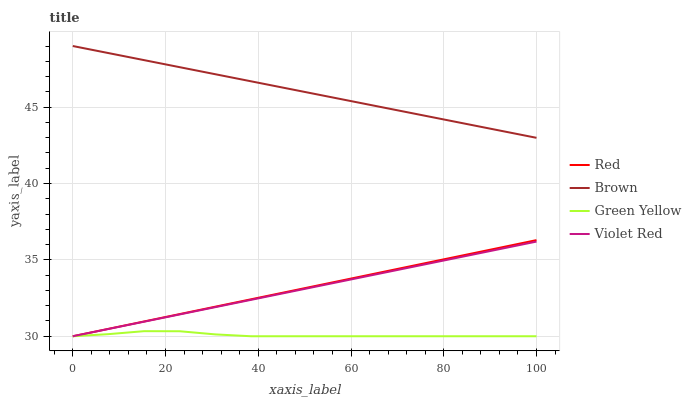Does Green Yellow have the minimum area under the curve?
Answer yes or no. Yes. Does Brown have the maximum area under the curve?
Answer yes or no. Yes. Does Violet Red have the minimum area under the curve?
Answer yes or no. No. Does Violet Red have the maximum area under the curve?
Answer yes or no. No. Is Red the smoothest?
Answer yes or no. Yes. Is Green Yellow the roughest?
Answer yes or no. Yes. Is Violet Red the smoothest?
Answer yes or no. No. Is Violet Red the roughest?
Answer yes or no. No. Does Brown have the highest value?
Answer yes or no. Yes. Does Violet Red have the highest value?
Answer yes or no. No. Is Red less than Brown?
Answer yes or no. Yes. Is Brown greater than Violet Red?
Answer yes or no. Yes. Does Violet Red intersect Green Yellow?
Answer yes or no. Yes. Is Violet Red less than Green Yellow?
Answer yes or no. No. Is Violet Red greater than Green Yellow?
Answer yes or no. No. Does Red intersect Brown?
Answer yes or no. No. 